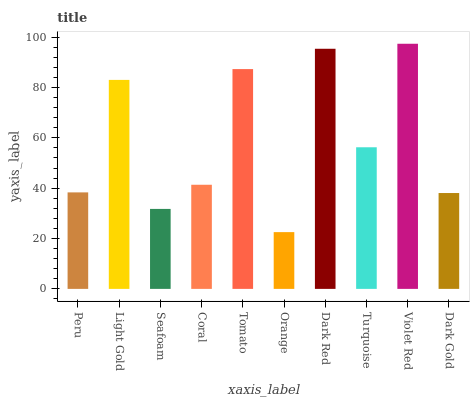Is Orange the minimum?
Answer yes or no. Yes. Is Violet Red the maximum?
Answer yes or no. Yes. Is Light Gold the minimum?
Answer yes or no. No. Is Light Gold the maximum?
Answer yes or no. No. Is Light Gold greater than Peru?
Answer yes or no. Yes. Is Peru less than Light Gold?
Answer yes or no. Yes. Is Peru greater than Light Gold?
Answer yes or no. No. Is Light Gold less than Peru?
Answer yes or no. No. Is Turquoise the high median?
Answer yes or no. Yes. Is Coral the low median?
Answer yes or no. Yes. Is Dark Red the high median?
Answer yes or no. No. Is Violet Red the low median?
Answer yes or no. No. 